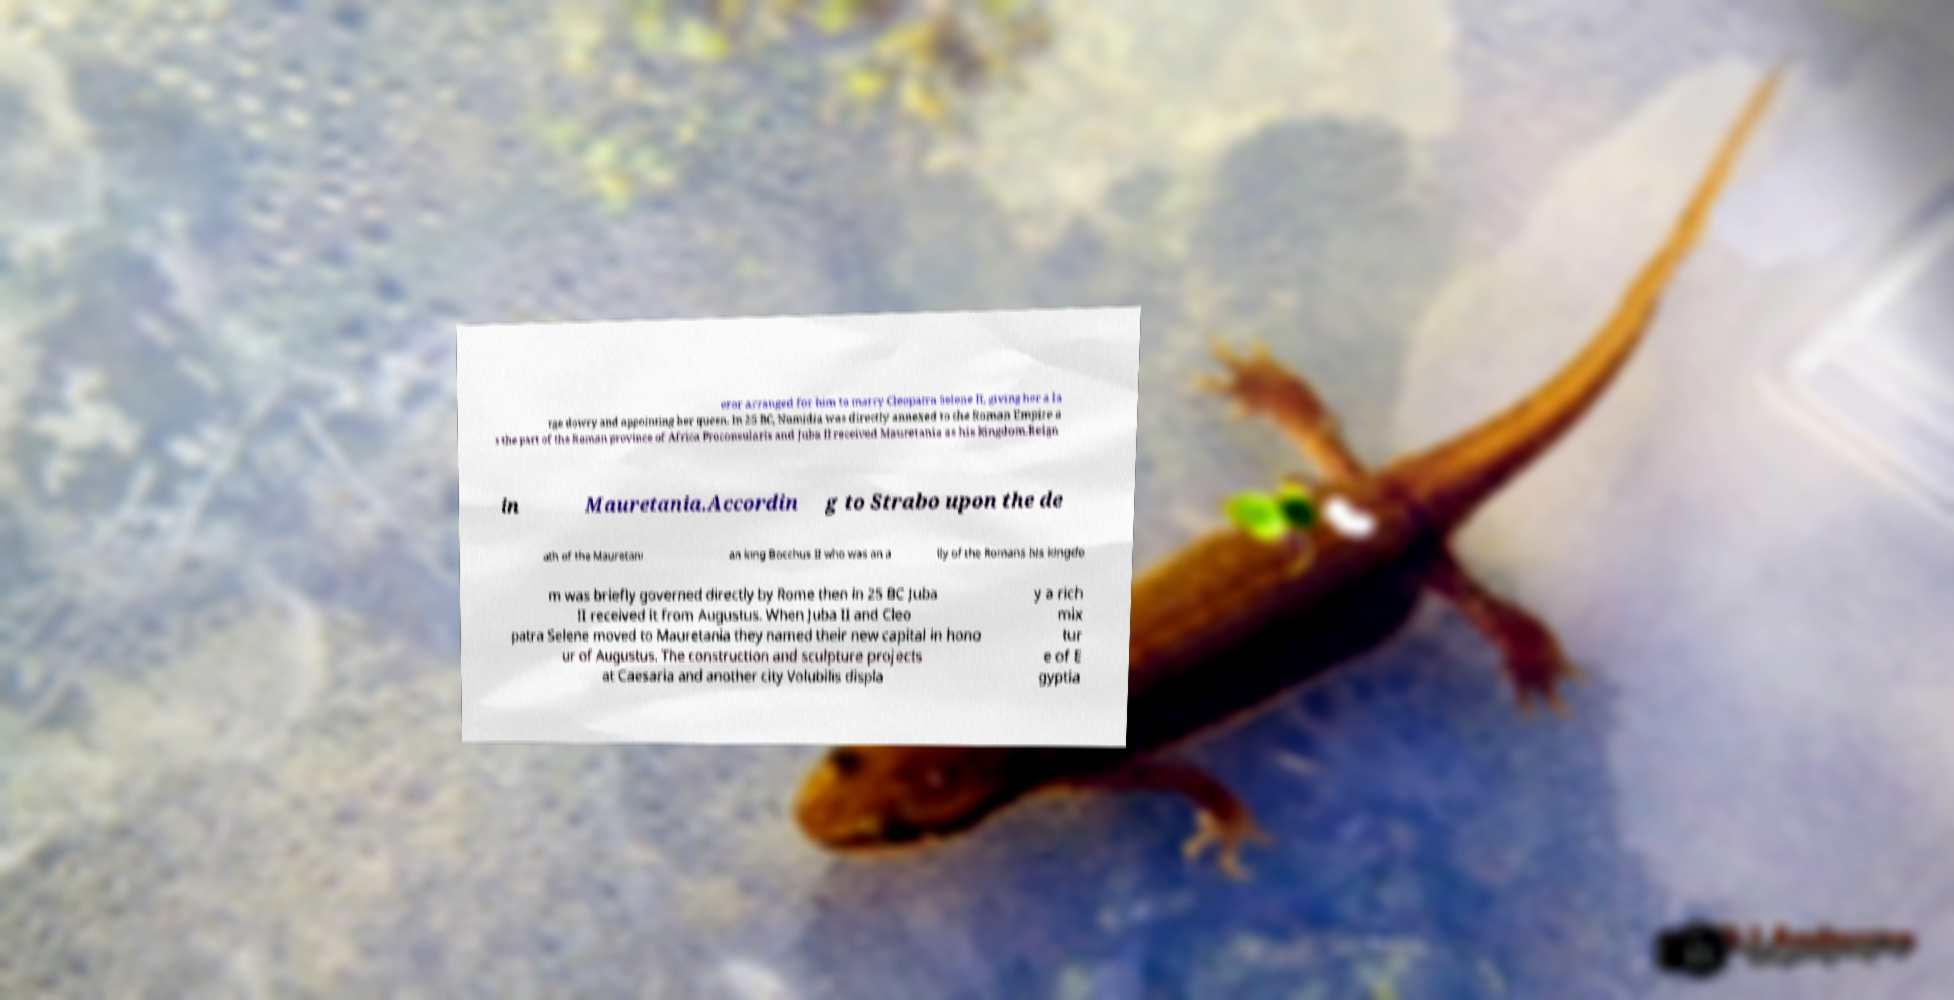I need the written content from this picture converted into text. Can you do that? eror arranged for him to marry Cleopatra Selene II, giving her a la rge dowry and appointing her queen. In 25 BC, Numidia was directly annexed to the Roman Empire a s the part of the Roman province of Africa Proconsularis and Juba II received Mauretania as his kingdom.Reign in Mauretania.Accordin g to Strabo upon the de ath of the Mauretani an king Bocchus II who was an a lly of the Romans his kingdo m was briefly governed directly by Rome then in 25 BC Juba II received it from Augustus. When Juba II and Cleo patra Selene moved to Mauretania they named their new capital in hono ur of Augustus. The construction and sculpture projects at Caesaria and another city Volubilis displa y a rich mix tur e of E gyptia 